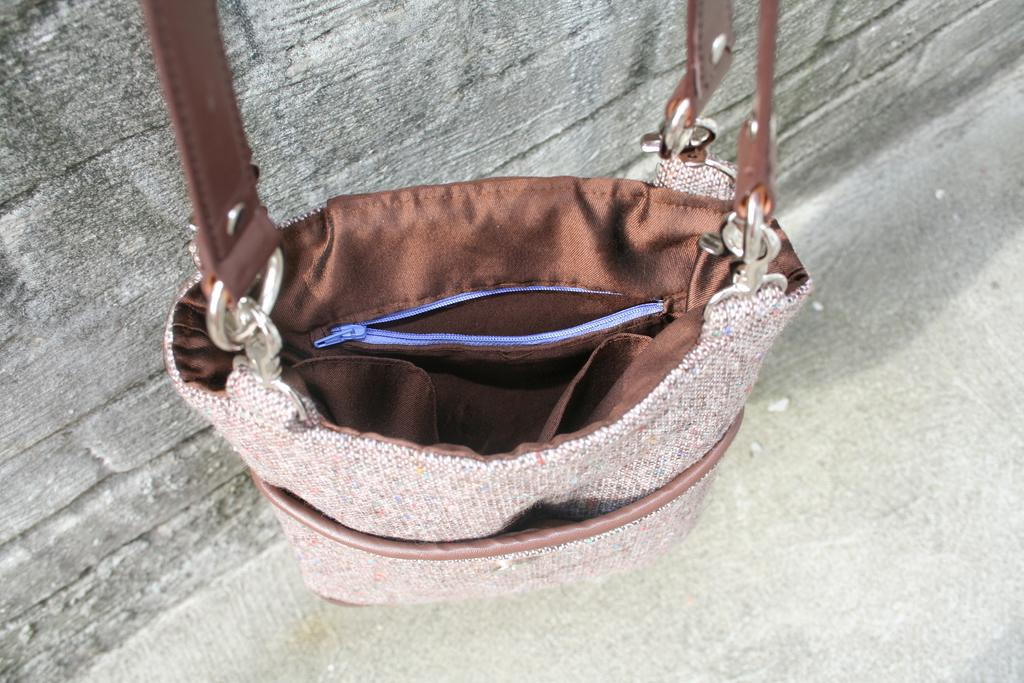What object can be seen in the image? There is a handbag in the image. What type of butter is being used to detail the handbag in the image? There is no butter or detailing present on the handbag in the image. Is there a ring attached to the handbag in the image? There is no ring visible on the handbag in the image. 